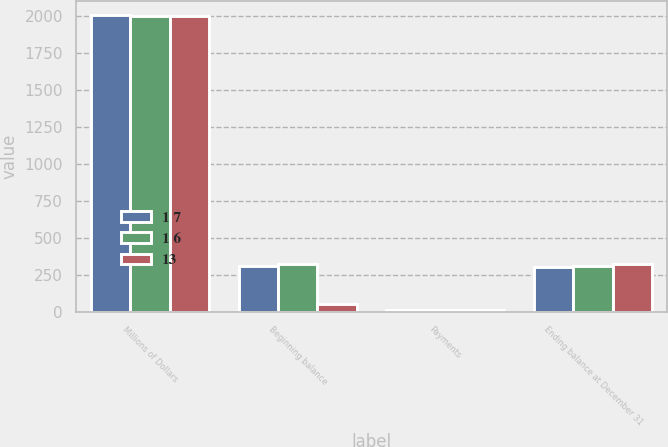Convert chart. <chart><loc_0><loc_0><loc_500><loc_500><stacked_bar_chart><ecel><fcel>Millions of Dollars<fcel>Beginning balance<fcel>Payments<fcel>Ending balance at December 31<nl><fcel>1 7<fcel>2006<fcel>311<fcel>9<fcel>302<nl><fcel>1 6<fcel>2005<fcel>324<fcel>13<fcel>311<nl><fcel>13<fcel>2004<fcel>51<fcel>14<fcel>324<nl></chart> 